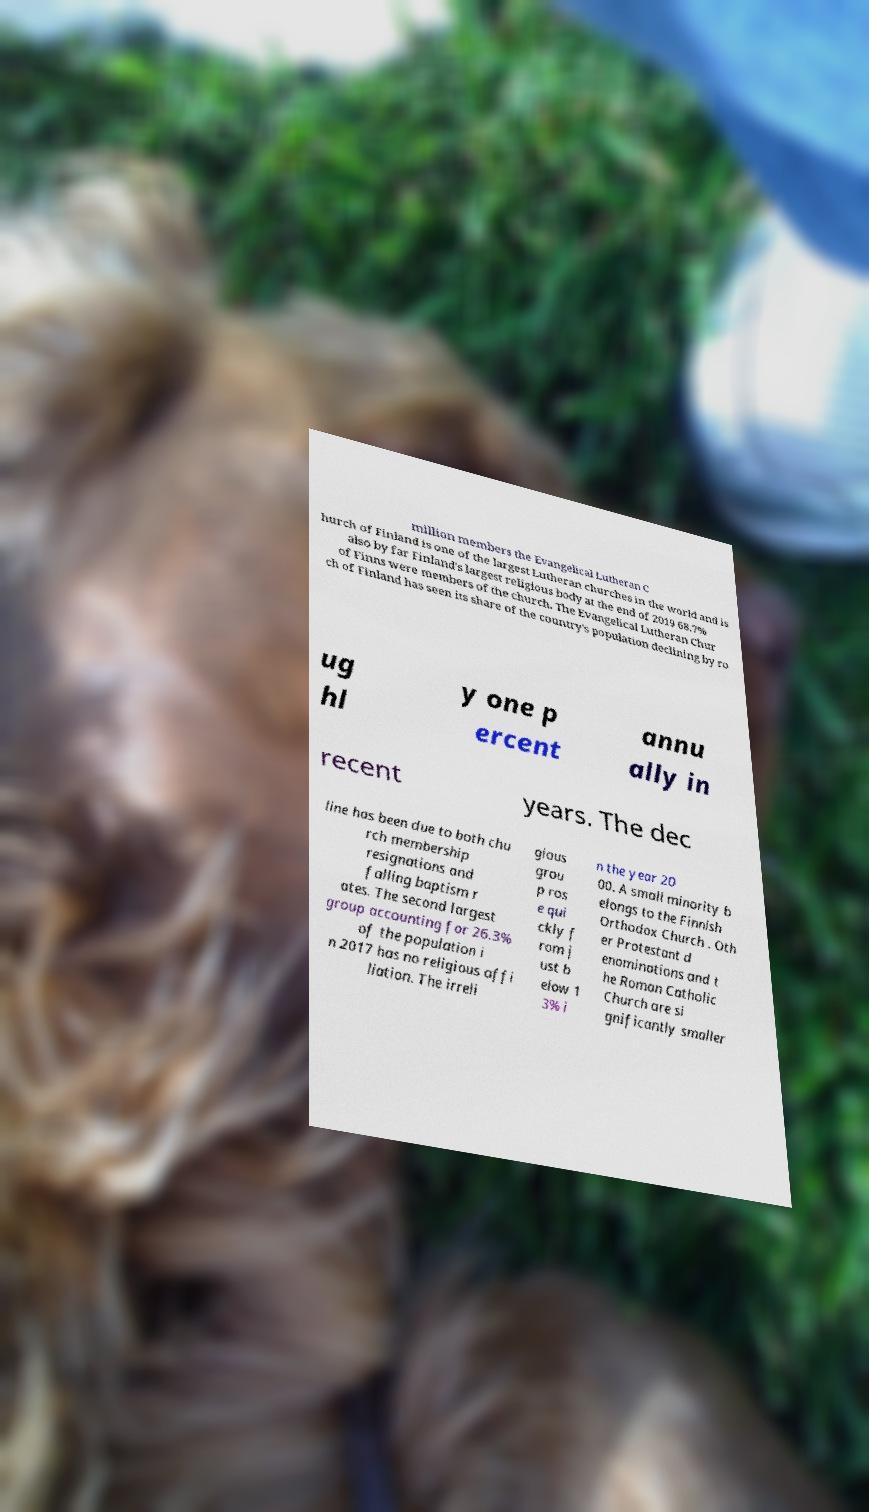Please read and relay the text visible in this image. What does it say? million members the Evangelical Lutheran C hurch of Finland is one of the largest Lutheran churches in the world and is also by far Finland's largest religious body at the end of 2019 68.7% of Finns were members of the church. The Evangelical Lutheran Chur ch of Finland has seen its share of the country's population declining by ro ug hl y one p ercent annu ally in recent years. The dec line has been due to both chu rch membership resignations and falling baptism r ates. The second largest group accounting for 26.3% of the population i n 2017 has no religious affi liation. The irreli gious grou p ros e qui ckly f rom j ust b elow 1 3% i n the year 20 00. A small minority b elongs to the Finnish Orthodox Church . Oth er Protestant d enominations and t he Roman Catholic Church are si gnificantly smaller 